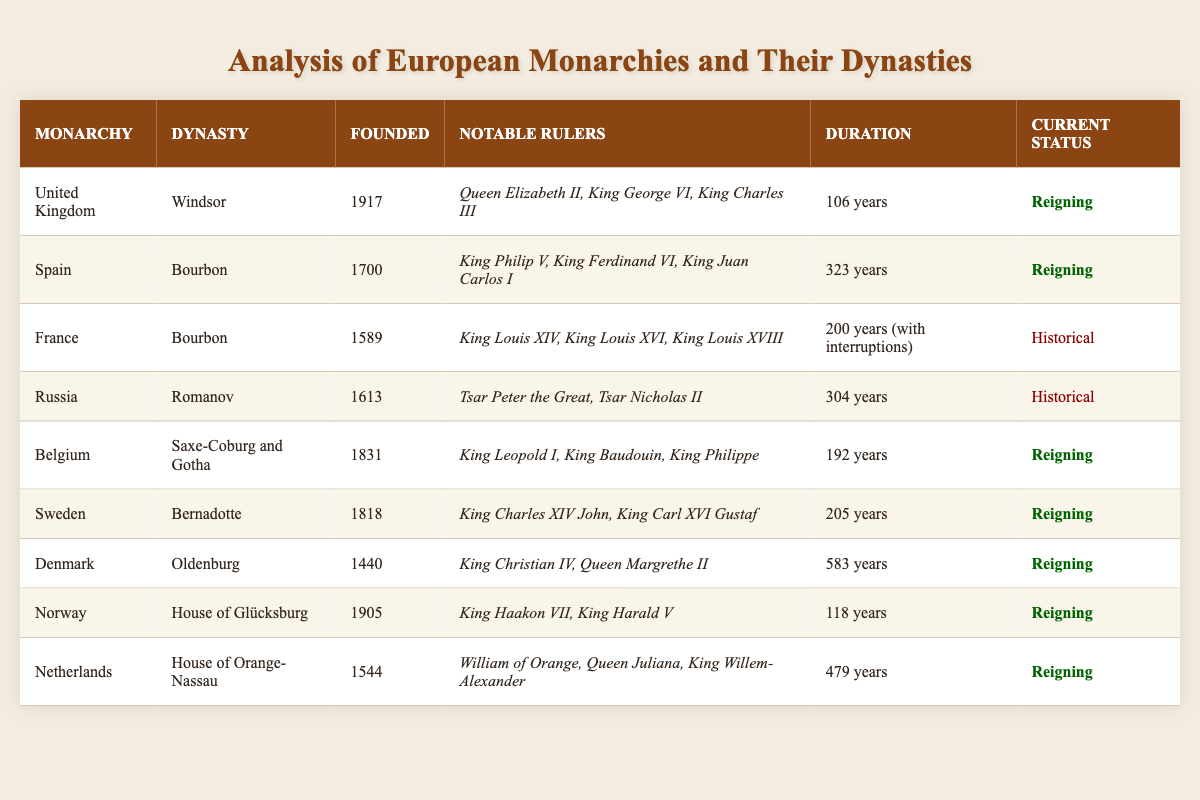What is the current status of the French monarchy? According to the table, the current status of the French monarchy is categorized as "Historical." This status indicates that the monarchy is no longer reigning and may have been abolished or transitioned into a different form of governance.
Answer: Historical Which monarchy has the longest duration? By examining the 'Duration' column, Denmark's monarchy lasts for 583 years, which is the highest among the listed monarchies. This can be confirmed by checking the duration values for each monarchy in the table.
Answer: 583 years How many notable rulers are associated with the Spanish monarchy? Looking at the notable rulers listed for the Spanish monarchy in the table, there are three named: King Philip V, King Ferdinand VI, and King Juan Carlos I. Thus, the count of notable rulers is straightforward as it directly refers to the items in the notable rulers' list.
Answer: 3 Which dynasties are currently reigning? The dynasties marked as "Reigning" in the table are Windsor, Bourbon, Saxe-Coburg and Gotha, Bernadotte, Oldenburg, House of Glücksburg, and House of Orange-Nassau. This determination is made based on the 'Current Status' column, specifically filtering out those that indicate they are reigning.
Answer: Windsor, Bourbon, Saxe-Coburg and Gotha, Bernadotte, Oldenburg, House of Glücksburg, House of Orange-Nassau What is the average founding year of the reigning monarchies? The founding years for the reigning monarchies are: 1917 (UK), 1700 (Spain), 1831 (Belgium), 1818 (Sweden), 1440 (Denmark), 1905 (Norway), and 1544 (Netherlands). Adding these years gives a total of 1917 + 1700 + 1831 + 1818 + 1440 + 1905 + 1544 = 11155. There are 7 reigning monarchies; therefore, the average founding year can be calculated by dividing the total (11155) by 7, which results in 1594.29. Rounding to the nearest year, we can approximate it as 1594.
Answer: 1594 Does the Dutch monarchy have more notable rulers than the Danish monarchy? The notable rulers for the Dutch monarchy are William of Orange, Queen Juliana, and King Willem-Alexander, totaling 3. The Danish monarchy's notable rulers are King Christian IV and Queen Margrethe II, totaling 2. Since 3 is greater than 2, we conclude that the Dutch monarchy has more notable rulers than the Danish monarchy.
Answer: Yes 